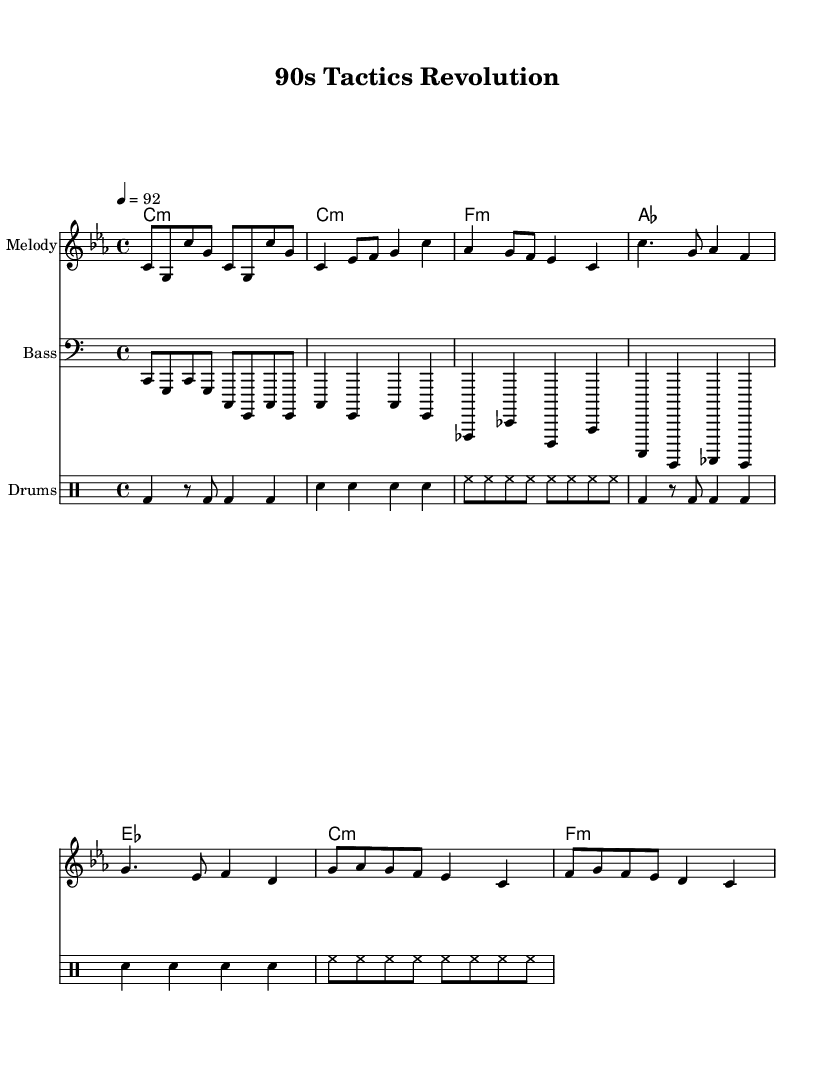What is the key signature of this music? The key signature is C minor, which has three flats: B flat, E flat, and A flat. This can be determined by looking at the key signature section of the sheet music where the flats are noted.
Answer: C minor What is the time signature of this music? The time signature is 4/4, indicated by the numbers at the beginning of the piece, which means there are four beats in each measure and the quarter note gets one beat.
Answer: 4/4 What is the tempo marking of this music? The tempo marking is 92 beats per minute, shown at the start of the music as "4 = 92". This indicates how fast the piece should be played.
Answer: 92 How many measures are in the verse section? The verse section consists of 2 measures, as seen in the sheet music where the melody transitions into the chorus after those 2 measures.
Answer: 2 What type of rap is this piece categorized under? This piece is categorized under English-language rap that chronicles the evolution of football tactics, evident through its thematic elements and lyrical focus described in the title.
Answer: English-language rap What instrument plays the bass line? The bass line is played by a bass instrument, which is indicated by the "Bass" staff label on the sheet music. This instrument typically supports the harmonic foundation of the piece.
Answer: Bass What rhythmic style is represented in the drum pattern? The drum pattern reflects a hip-hop style characterized by a standard kick-snare pattern along with hi-hats, common in rap music for creating a strong rhythmic groove.
Answer: Hip-hop style 